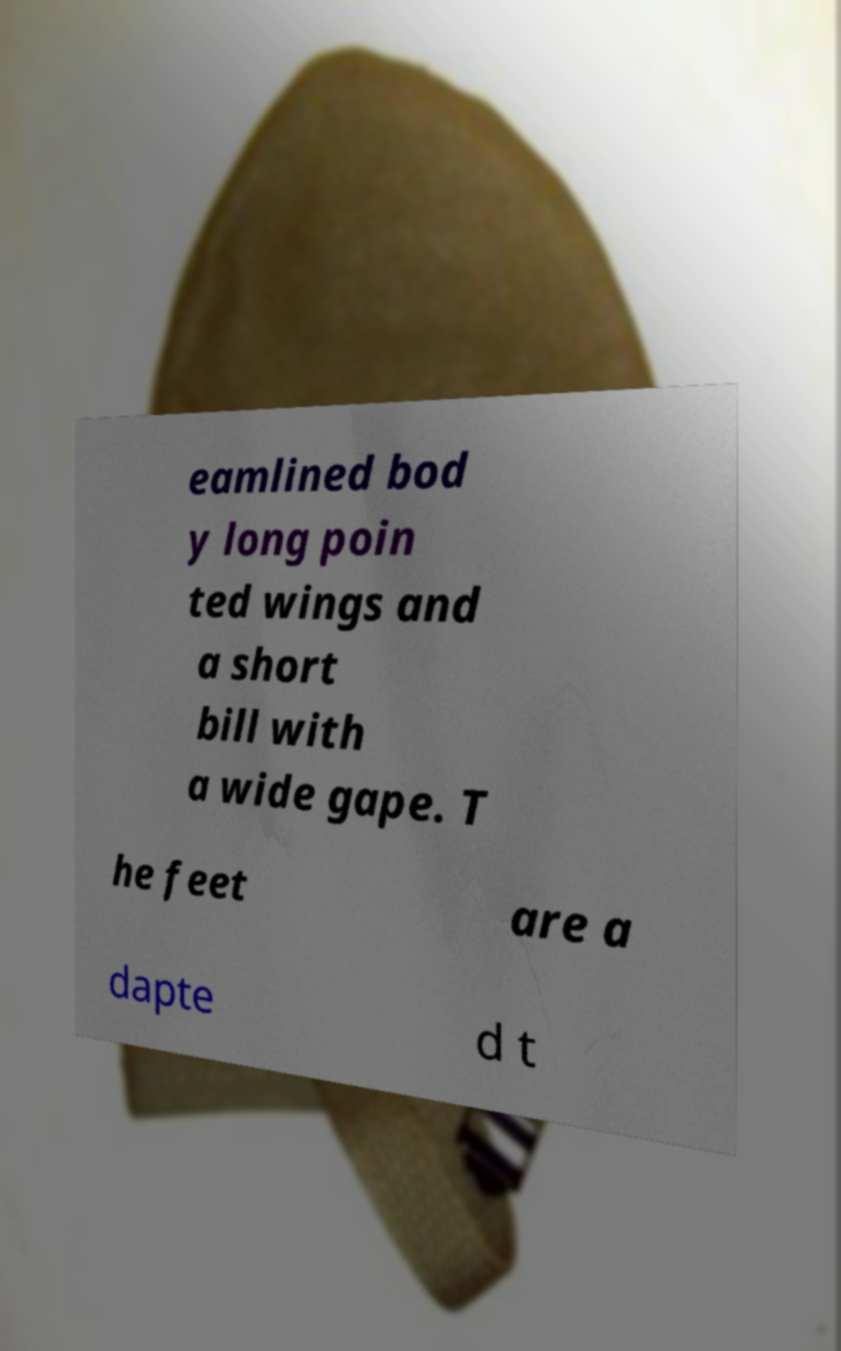Could you assist in decoding the text presented in this image and type it out clearly? eamlined bod y long poin ted wings and a short bill with a wide gape. T he feet are a dapte d t 